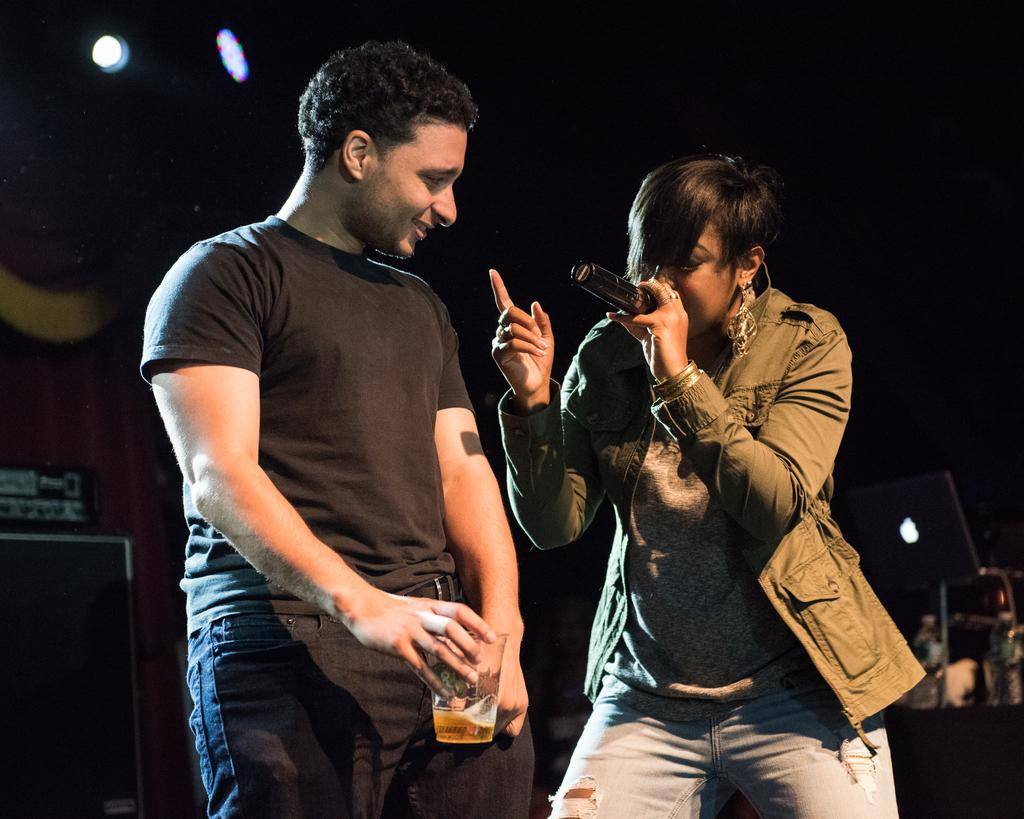What is the man in the image holding? The man is holding a glass of alcohol. What is the woman in the image holding? The woman is holding a microphone. Can you describe the time of day when the image was taken? The image was taken during night time. What can be seen in the image that indicates the presence of light? Lights are visible in the image. What type of car can be seen in the image? There is no car present in the image. What is the woman using to fly in the image? The woman is not flying in the image; she is holding a microphone. 